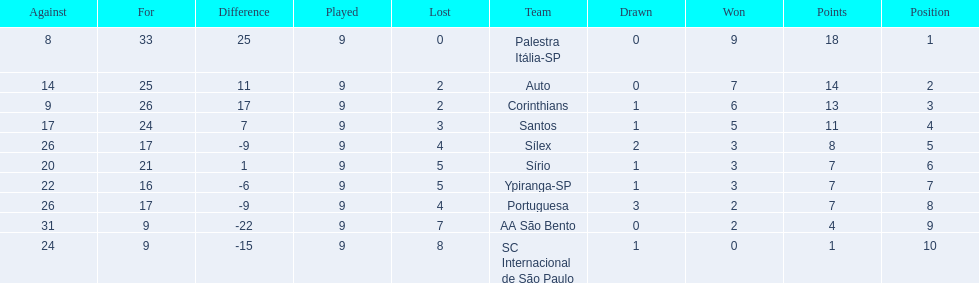Can you give me this table as a dict? {'header': ['Against', 'For', 'Difference', 'Played', 'Lost', 'Team', 'Drawn', 'Won', 'Points', 'Position'], 'rows': [['8', '33', '25', '9', '0', 'Palestra Itália-SP', '0', '9', '18', '1'], ['14', '25', '11', '9', '2', 'Auto', '0', '7', '14', '2'], ['9', '26', '17', '9', '2', 'Corinthians', '1', '6', '13', '3'], ['17', '24', '7', '9', '3', 'Santos', '1', '5', '11', '4'], ['26', '17', '-9', '9', '4', 'Sílex', '2', '3', '8', '5'], ['20', '21', '1', '9', '5', 'Sírio', '1', '3', '7', '6'], ['22', '16', '-6', '9', '5', 'Ypiranga-SP', '1', '3', '7', '7'], ['26', '17', '-9', '9', '4', 'Portuguesa', '3', '2', '7', '8'], ['31', '9', '-22', '9', '7', 'AA São Bento', '0', '2', '4', '9'], ['24', '9', '-15', '9', '8', 'SC Internacional de São Paulo', '1', '0', '1', '10']]} How many games did each team play? 9, 9, 9, 9, 9, 9, 9, 9, 9, 9. Did any team score 13 points in the total games they played? 13. What is the name of that team? Corinthians. 